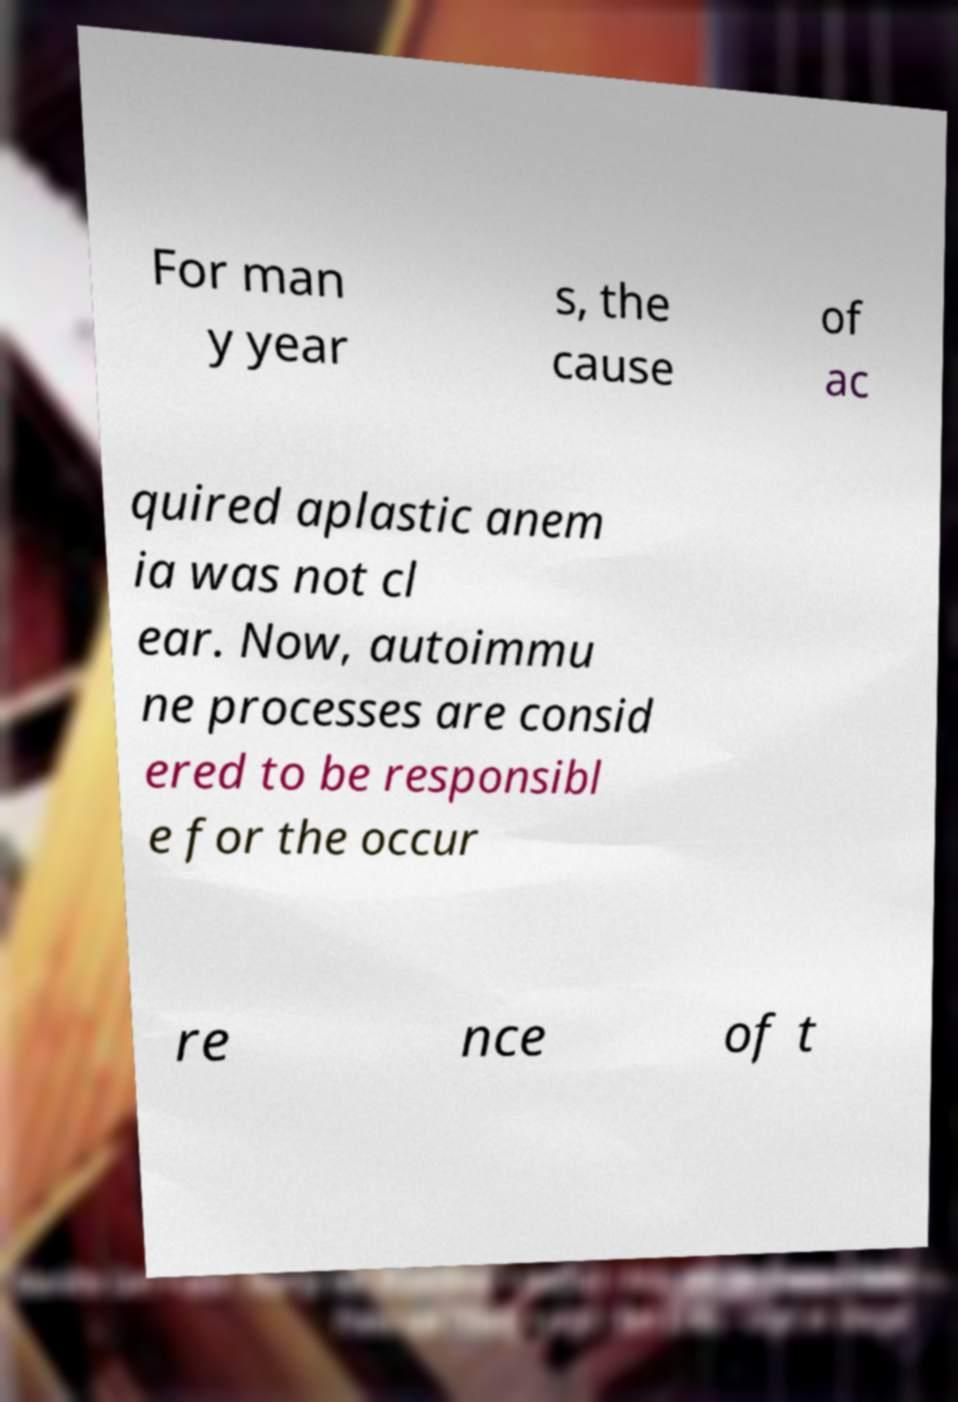Please read and relay the text visible in this image. What does it say? For man y year s, the cause of ac quired aplastic anem ia was not cl ear. Now, autoimmu ne processes are consid ered to be responsibl e for the occur re nce of t 